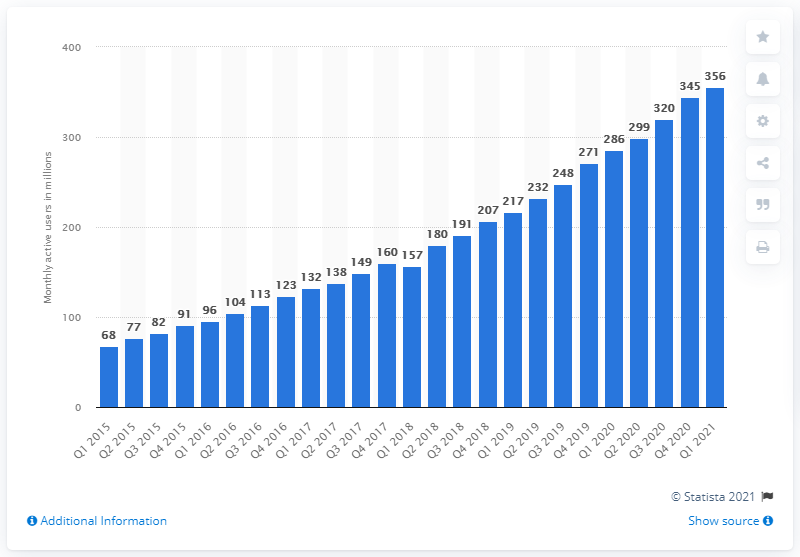Draw attention to some important aspects in this diagram. As of the first quarter of 2021, Spotify had a total of 356 active users. 